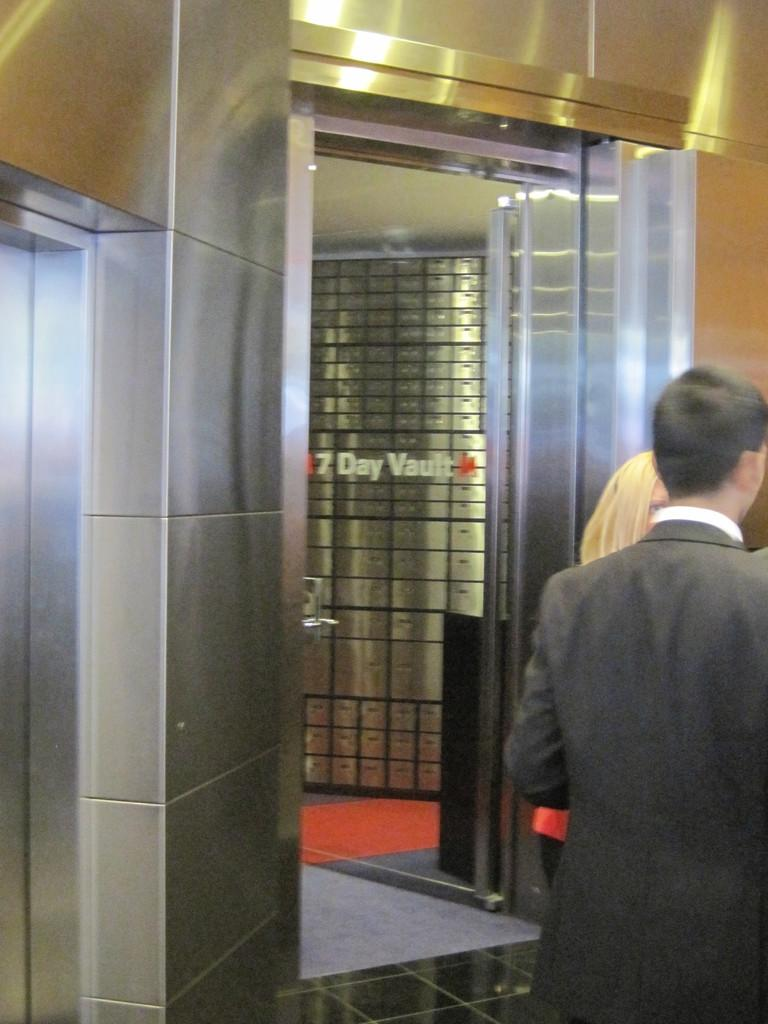What are the main subjects in the image? There are persons standing in the center of the image. Where are the persons standing? The persons are standing on the floor. What can be seen in the background of the image? There is an elevator, a door, and a wall in the background of the image. What type of thrill can be seen on the root of the owl in the image? There is no owl or root present in the image, so it is not possible to determine if there is any thrill associated with them. 